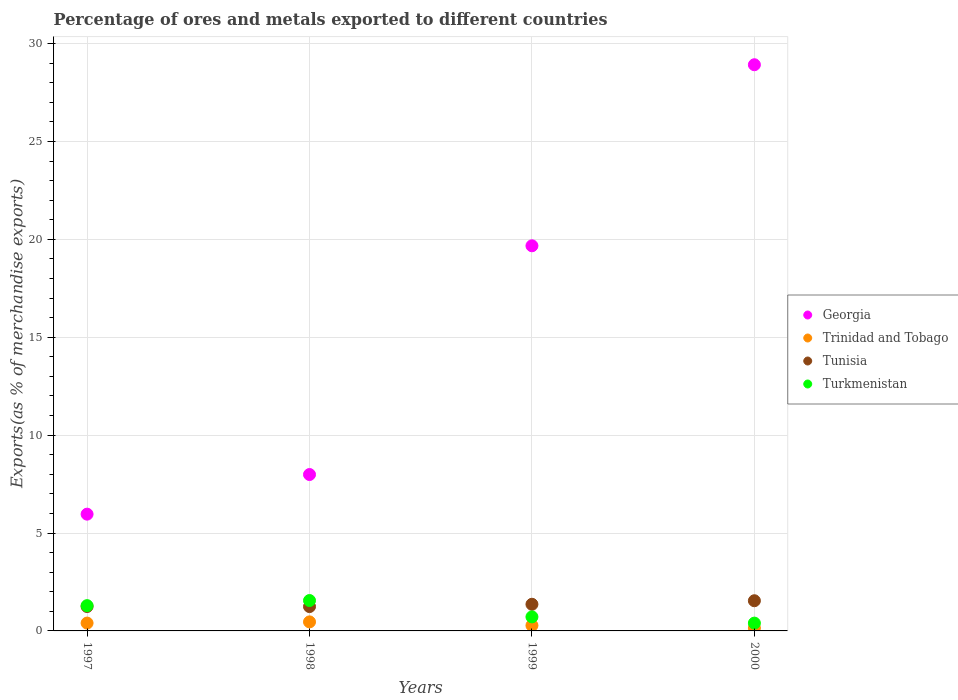Is the number of dotlines equal to the number of legend labels?
Provide a succinct answer. Yes. What is the percentage of exports to different countries in Trinidad and Tobago in 1999?
Make the answer very short. 0.28. Across all years, what is the maximum percentage of exports to different countries in Tunisia?
Your answer should be compact. 1.54. Across all years, what is the minimum percentage of exports to different countries in Trinidad and Tobago?
Keep it short and to the point. 0.15. In which year was the percentage of exports to different countries in Turkmenistan minimum?
Provide a succinct answer. 2000. What is the total percentage of exports to different countries in Georgia in the graph?
Your answer should be compact. 62.54. What is the difference between the percentage of exports to different countries in Trinidad and Tobago in 1998 and that in 2000?
Offer a very short reply. 0.31. What is the difference between the percentage of exports to different countries in Tunisia in 1998 and the percentage of exports to different countries in Trinidad and Tobago in 2000?
Your answer should be very brief. 1.1. What is the average percentage of exports to different countries in Trinidad and Tobago per year?
Make the answer very short. 0.32. In the year 2000, what is the difference between the percentage of exports to different countries in Tunisia and percentage of exports to different countries in Trinidad and Tobago?
Provide a succinct answer. 1.39. What is the ratio of the percentage of exports to different countries in Tunisia in 1998 to that in 2000?
Keep it short and to the point. 0.81. Is the percentage of exports to different countries in Georgia in 1997 less than that in 1998?
Make the answer very short. Yes. Is the difference between the percentage of exports to different countries in Tunisia in 1999 and 2000 greater than the difference between the percentage of exports to different countries in Trinidad and Tobago in 1999 and 2000?
Provide a short and direct response. No. What is the difference between the highest and the second highest percentage of exports to different countries in Tunisia?
Provide a short and direct response. 0.18. What is the difference between the highest and the lowest percentage of exports to different countries in Tunisia?
Give a very brief answer. 0.3. In how many years, is the percentage of exports to different countries in Turkmenistan greater than the average percentage of exports to different countries in Turkmenistan taken over all years?
Make the answer very short. 2. Is the sum of the percentage of exports to different countries in Georgia in 1997 and 1998 greater than the maximum percentage of exports to different countries in Tunisia across all years?
Give a very brief answer. Yes. Is it the case that in every year, the sum of the percentage of exports to different countries in Georgia and percentage of exports to different countries in Turkmenistan  is greater than the sum of percentage of exports to different countries in Tunisia and percentage of exports to different countries in Trinidad and Tobago?
Give a very brief answer. Yes. Is the percentage of exports to different countries in Georgia strictly greater than the percentage of exports to different countries in Turkmenistan over the years?
Your answer should be very brief. Yes. Is the percentage of exports to different countries in Georgia strictly less than the percentage of exports to different countries in Trinidad and Tobago over the years?
Make the answer very short. No. What is the difference between two consecutive major ticks on the Y-axis?
Offer a terse response. 5. Are the values on the major ticks of Y-axis written in scientific E-notation?
Your answer should be compact. No. Does the graph contain grids?
Offer a terse response. Yes. Where does the legend appear in the graph?
Offer a very short reply. Center right. How many legend labels are there?
Ensure brevity in your answer.  4. What is the title of the graph?
Your answer should be compact. Percentage of ores and metals exported to different countries. Does "Maldives" appear as one of the legend labels in the graph?
Keep it short and to the point. No. What is the label or title of the Y-axis?
Provide a succinct answer. Exports(as % of merchandise exports). What is the Exports(as % of merchandise exports) of Georgia in 1997?
Give a very brief answer. 5.96. What is the Exports(as % of merchandise exports) of Trinidad and Tobago in 1997?
Your answer should be very brief. 0.4. What is the Exports(as % of merchandise exports) of Tunisia in 1997?
Provide a short and direct response. 1.25. What is the Exports(as % of merchandise exports) of Turkmenistan in 1997?
Ensure brevity in your answer.  1.29. What is the Exports(as % of merchandise exports) in Georgia in 1998?
Offer a terse response. 7.99. What is the Exports(as % of merchandise exports) of Trinidad and Tobago in 1998?
Your response must be concise. 0.46. What is the Exports(as % of merchandise exports) in Tunisia in 1998?
Provide a succinct answer. 1.24. What is the Exports(as % of merchandise exports) of Turkmenistan in 1998?
Provide a succinct answer. 1.55. What is the Exports(as % of merchandise exports) of Georgia in 1999?
Your answer should be very brief. 19.67. What is the Exports(as % of merchandise exports) in Trinidad and Tobago in 1999?
Give a very brief answer. 0.28. What is the Exports(as % of merchandise exports) in Tunisia in 1999?
Keep it short and to the point. 1.36. What is the Exports(as % of merchandise exports) in Turkmenistan in 1999?
Give a very brief answer. 0.72. What is the Exports(as % of merchandise exports) of Georgia in 2000?
Keep it short and to the point. 28.92. What is the Exports(as % of merchandise exports) of Trinidad and Tobago in 2000?
Make the answer very short. 0.15. What is the Exports(as % of merchandise exports) of Tunisia in 2000?
Offer a terse response. 1.54. What is the Exports(as % of merchandise exports) in Turkmenistan in 2000?
Give a very brief answer. 0.4. Across all years, what is the maximum Exports(as % of merchandise exports) in Georgia?
Provide a succinct answer. 28.92. Across all years, what is the maximum Exports(as % of merchandise exports) of Trinidad and Tobago?
Provide a succinct answer. 0.46. Across all years, what is the maximum Exports(as % of merchandise exports) of Tunisia?
Offer a terse response. 1.54. Across all years, what is the maximum Exports(as % of merchandise exports) of Turkmenistan?
Offer a terse response. 1.55. Across all years, what is the minimum Exports(as % of merchandise exports) in Georgia?
Your answer should be very brief. 5.96. Across all years, what is the minimum Exports(as % of merchandise exports) of Trinidad and Tobago?
Your answer should be compact. 0.15. Across all years, what is the minimum Exports(as % of merchandise exports) of Tunisia?
Your answer should be compact. 1.24. Across all years, what is the minimum Exports(as % of merchandise exports) of Turkmenistan?
Provide a succinct answer. 0.4. What is the total Exports(as % of merchandise exports) in Georgia in the graph?
Make the answer very short. 62.54. What is the total Exports(as % of merchandise exports) in Trinidad and Tobago in the graph?
Give a very brief answer. 1.29. What is the total Exports(as % of merchandise exports) in Tunisia in the graph?
Ensure brevity in your answer.  5.39. What is the total Exports(as % of merchandise exports) in Turkmenistan in the graph?
Provide a short and direct response. 3.96. What is the difference between the Exports(as % of merchandise exports) in Georgia in 1997 and that in 1998?
Your answer should be compact. -2.02. What is the difference between the Exports(as % of merchandise exports) of Trinidad and Tobago in 1997 and that in 1998?
Offer a terse response. -0.06. What is the difference between the Exports(as % of merchandise exports) in Tunisia in 1997 and that in 1998?
Give a very brief answer. 0. What is the difference between the Exports(as % of merchandise exports) in Turkmenistan in 1997 and that in 1998?
Offer a terse response. -0.26. What is the difference between the Exports(as % of merchandise exports) of Georgia in 1997 and that in 1999?
Offer a very short reply. -13.71. What is the difference between the Exports(as % of merchandise exports) of Trinidad and Tobago in 1997 and that in 1999?
Provide a short and direct response. 0.12. What is the difference between the Exports(as % of merchandise exports) of Tunisia in 1997 and that in 1999?
Offer a very short reply. -0.11. What is the difference between the Exports(as % of merchandise exports) of Turkmenistan in 1997 and that in 1999?
Ensure brevity in your answer.  0.57. What is the difference between the Exports(as % of merchandise exports) of Georgia in 1997 and that in 2000?
Your answer should be compact. -22.95. What is the difference between the Exports(as % of merchandise exports) in Trinidad and Tobago in 1997 and that in 2000?
Keep it short and to the point. 0.25. What is the difference between the Exports(as % of merchandise exports) of Tunisia in 1997 and that in 2000?
Your response must be concise. -0.3. What is the difference between the Exports(as % of merchandise exports) in Turkmenistan in 1997 and that in 2000?
Make the answer very short. 0.89. What is the difference between the Exports(as % of merchandise exports) of Georgia in 1998 and that in 1999?
Offer a very short reply. -11.68. What is the difference between the Exports(as % of merchandise exports) in Trinidad and Tobago in 1998 and that in 1999?
Give a very brief answer. 0.18. What is the difference between the Exports(as % of merchandise exports) of Tunisia in 1998 and that in 1999?
Offer a very short reply. -0.12. What is the difference between the Exports(as % of merchandise exports) in Turkmenistan in 1998 and that in 1999?
Keep it short and to the point. 0.83. What is the difference between the Exports(as % of merchandise exports) in Georgia in 1998 and that in 2000?
Provide a short and direct response. -20.93. What is the difference between the Exports(as % of merchandise exports) in Trinidad and Tobago in 1998 and that in 2000?
Your response must be concise. 0.31. What is the difference between the Exports(as % of merchandise exports) in Tunisia in 1998 and that in 2000?
Your response must be concise. -0.3. What is the difference between the Exports(as % of merchandise exports) of Turkmenistan in 1998 and that in 2000?
Ensure brevity in your answer.  1.15. What is the difference between the Exports(as % of merchandise exports) of Georgia in 1999 and that in 2000?
Offer a terse response. -9.25. What is the difference between the Exports(as % of merchandise exports) in Trinidad and Tobago in 1999 and that in 2000?
Keep it short and to the point. 0.13. What is the difference between the Exports(as % of merchandise exports) of Tunisia in 1999 and that in 2000?
Ensure brevity in your answer.  -0.18. What is the difference between the Exports(as % of merchandise exports) in Turkmenistan in 1999 and that in 2000?
Make the answer very short. 0.32. What is the difference between the Exports(as % of merchandise exports) of Georgia in 1997 and the Exports(as % of merchandise exports) of Trinidad and Tobago in 1998?
Provide a short and direct response. 5.5. What is the difference between the Exports(as % of merchandise exports) in Georgia in 1997 and the Exports(as % of merchandise exports) in Tunisia in 1998?
Your answer should be compact. 4.72. What is the difference between the Exports(as % of merchandise exports) of Georgia in 1997 and the Exports(as % of merchandise exports) of Turkmenistan in 1998?
Offer a very short reply. 4.41. What is the difference between the Exports(as % of merchandise exports) of Trinidad and Tobago in 1997 and the Exports(as % of merchandise exports) of Tunisia in 1998?
Give a very brief answer. -0.84. What is the difference between the Exports(as % of merchandise exports) in Trinidad and Tobago in 1997 and the Exports(as % of merchandise exports) in Turkmenistan in 1998?
Your response must be concise. -1.15. What is the difference between the Exports(as % of merchandise exports) of Tunisia in 1997 and the Exports(as % of merchandise exports) of Turkmenistan in 1998?
Your answer should be very brief. -0.31. What is the difference between the Exports(as % of merchandise exports) in Georgia in 1997 and the Exports(as % of merchandise exports) in Trinidad and Tobago in 1999?
Offer a terse response. 5.69. What is the difference between the Exports(as % of merchandise exports) in Georgia in 1997 and the Exports(as % of merchandise exports) in Tunisia in 1999?
Your response must be concise. 4.6. What is the difference between the Exports(as % of merchandise exports) of Georgia in 1997 and the Exports(as % of merchandise exports) of Turkmenistan in 1999?
Ensure brevity in your answer.  5.25. What is the difference between the Exports(as % of merchandise exports) of Trinidad and Tobago in 1997 and the Exports(as % of merchandise exports) of Tunisia in 1999?
Ensure brevity in your answer.  -0.96. What is the difference between the Exports(as % of merchandise exports) of Trinidad and Tobago in 1997 and the Exports(as % of merchandise exports) of Turkmenistan in 1999?
Offer a terse response. -0.32. What is the difference between the Exports(as % of merchandise exports) in Tunisia in 1997 and the Exports(as % of merchandise exports) in Turkmenistan in 1999?
Give a very brief answer. 0.53. What is the difference between the Exports(as % of merchandise exports) of Georgia in 1997 and the Exports(as % of merchandise exports) of Trinidad and Tobago in 2000?
Offer a very short reply. 5.82. What is the difference between the Exports(as % of merchandise exports) in Georgia in 1997 and the Exports(as % of merchandise exports) in Tunisia in 2000?
Your answer should be very brief. 4.42. What is the difference between the Exports(as % of merchandise exports) of Georgia in 1997 and the Exports(as % of merchandise exports) of Turkmenistan in 2000?
Provide a short and direct response. 5.56. What is the difference between the Exports(as % of merchandise exports) in Trinidad and Tobago in 1997 and the Exports(as % of merchandise exports) in Tunisia in 2000?
Your response must be concise. -1.14. What is the difference between the Exports(as % of merchandise exports) in Trinidad and Tobago in 1997 and the Exports(as % of merchandise exports) in Turkmenistan in 2000?
Your answer should be compact. 0. What is the difference between the Exports(as % of merchandise exports) in Tunisia in 1997 and the Exports(as % of merchandise exports) in Turkmenistan in 2000?
Your answer should be compact. 0.85. What is the difference between the Exports(as % of merchandise exports) of Georgia in 1998 and the Exports(as % of merchandise exports) of Trinidad and Tobago in 1999?
Provide a short and direct response. 7.71. What is the difference between the Exports(as % of merchandise exports) of Georgia in 1998 and the Exports(as % of merchandise exports) of Tunisia in 1999?
Your answer should be compact. 6.63. What is the difference between the Exports(as % of merchandise exports) of Georgia in 1998 and the Exports(as % of merchandise exports) of Turkmenistan in 1999?
Your answer should be very brief. 7.27. What is the difference between the Exports(as % of merchandise exports) in Trinidad and Tobago in 1998 and the Exports(as % of merchandise exports) in Tunisia in 1999?
Make the answer very short. -0.9. What is the difference between the Exports(as % of merchandise exports) of Trinidad and Tobago in 1998 and the Exports(as % of merchandise exports) of Turkmenistan in 1999?
Give a very brief answer. -0.26. What is the difference between the Exports(as % of merchandise exports) of Tunisia in 1998 and the Exports(as % of merchandise exports) of Turkmenistan in 1999?
Your answer should be very brief. 0.53. What is the difference between the Exports(as % of merchandise exports) in Georgia in 1998 and the Exports(as % of merchandise exports) in Trinidad and Tobago in 2000?
Your answer should be very brief. 7.84. What is the difference between the Exports(as % of merchandise exports) of Georgia in 1998 and the Exports(as % of merchandise exports) of Tunisia in 2000?
Give a very brief answer. 6.45. What is the difference between the Exports(as % of merchandise exports) of Georgia in 1998 and the Exports(as % of merchandise exports) of Turkmenistan in 2000?
Make the answer very short. 7.59. What is the difference between the Exports(as % of merchandise exports) of Trinidad and Tobago in 1998 and the Exports(as % of merchandise exports) of Tunisia in 2000?
Provide a succinct answer. -1.08. What is the difference between the Exports(as % of merchandise exports) of Trinidad and Tobago in 1998 and the Exports(as % of merchandise exports) of Turkmenistan in 2000?
Keep it short and to the point. 0.06. What is the difference between the Exports(as % of merchandise exports) of Tunisia in 1998 and the Exports(as % of merchandise exports) of Turkmenistan in 2000?
Your answer should be compact. 0.84. What is the difference between the Exports(as % of merchandise exports) of Georgia in 1999 and the Exports(as % of merchandise exports) of Trinidad and Tobago in 2000?
Provide a succinct answer. 19.52. What is the difference between the Exports(as % of merchandise exports) of Georgia in 1999 and the Exports(as % of merchandise exports) of Tunisia in 2000?
Keep it short and to the point. 18.13. What is the difference between the Exports(as % of merchandise exports) in Georgia in 1999 and the Exports(as % of merchandise exports) in Turkmenistan in 2000?
Your answer should be compact. 19.27. What is the difference between the Exports(as % of merchandise exports) of Trinidad and Tobago in 1999 and the Exports(as % of merchandise exports) of Tunisia in 2000?
Provide a short and direct response. -1.26. What is the difference between the Exports(as % of merchandise exports) in Trinidad and Tobago in 1999 and the Exports(as % of merchandise exports) in Turkmenistan in 2000?
Your answer should be compact. -0.12. What is the difference between the Exports(as % of merchandise exports) of Tunisia in 1999 and the Exports(as % of merchandise exports) of Turkmenistan in 2000?
Offer a very short reply. 0.96. What is the average Exports(as % of merchandise exports) of Georgia per year?
Offer a terse response. 15.63. What is the average Exports(as % of merchandise exports) in Trinidad and Tobago per year?
Keep it short and to the point. 0.32. What is the average Exports(as % of merchandise exports) in Tunisia per year?
Ensure brevity in your answer.  1.35. In the year 1997, what is the difference between the Exports(as % of merchandise exports) in Georgia and Exports(as % of merchandise exports) in Trinidad and Tobago?
Give a very brief answer. 5.56. In the year 1997, what is the difference between the Exports(as % of merchandise exports) of Georgia and Exports(as % of merchandise exports) of Tunisia?
Offer a terse response. 4.72. In the year 1997, what is the difference between the Exports(as % of merchandise exports) in Georgia and Exports(as % of merchandise exports) in Turkmenistan?
Your answer should be compact. 4.67. In the year 1997, what is the difference between the Exports(as % of merchandise exports) in Trinidad and Tobago and Exports(as % of merchandise exports) in Tunisia?
Your answer should be very brief. -0.85. In the year 1997, what is the difference between the Exports(as % of merchandise exports) of Trinidad and Tobago and Exports(as % of merchandise exports) of Turkmenistan?
Offer a very short reply. -0.89. In the year 1997, what is the difference between the Exports(as % of merchandise exports) of Tunisia and Exports(as % of merchandise exports) of Turkmenistan?
Ensure brevity in your answer.  -0.04. In the year 1998, what is the difference between the Exports(as % of merchandise exports) of Georgia and Exports(as % of merchandise exports) of Trinidad and Tobago?
Your response must be concise. 7.53. In the year 1998, what is the difference between the Exports(as % of merchandise exports) of Georgia and Exports(as % of merchandise exports) of Tunisia?
Make the answer very short. 6.74. In the year 1998, what is the difference between the Exports(as % of merchandise exports) of Georgia and Exports(as % of merchandise exports) of Turkmenistan?
Your response must be concise. 6.44. In the year 1998, what is the difference between the Exports(as % of merchandise exports) of Trinidad and Tobago and Exports(as % of merchandise exports) of Tunisia?
Your answer should be very brief. -0.78. In the year 1998, what is the difference between the Exports(as % of merchandise exports) in Trinidad and Tobago and Exports(as % of merchandise exports) in Turkmenistan?
Give a very brief answer. -1.09. In the year 1998, what is the difference between the Exports(as % of merchandise exports) of Tunisia and Exports(as % of merchandise exports) of Turkmenistan?
Your answer should be compact. -0.31. In the year 1999, what is the difference between the Exports(as % of merchandise exports) in Georgia and Exports(as % of merchandise exports) in Trinidad and Tobago?
Your answer should be compact. 19.39. In the year 1999, what is the difference between the Exports(as % of merchandise exports) of Georgia and Exports(as % of merchandise exports) of Tunisia?
Offer a very short reply. 18.31. In the year 1999, what is the difference between the Exports(as % of merchandise exports) in Georgia and Exports(as % of merchandise exports) in Turkmenistan?
Make the answer very short. 18.95. In the year 1999, what is the difference between the Exports(as % of merchandise exports) of Trinidad and Tobago and Exports(as % of merchandise exports) of Tunisia?
Provide a short and direct response. -1.08. In the year 1999, what is the difference between the Exports(as % of merchandise exports) in Trinidad and Tobago and Exports(as % of merchandise exports) in Turkmenistan?
Make the answer very short. -0.44. In the year 1999, what is the difference between the Exports(as % of merchandise exports) of Tunisia and Exports(as % of merchandise exports) of Turkmenistan?
Provide a succinct answer. 0.64. In the year 2000, what is the difference between the Exports(as % of merchandise exports) of Georgia and Exports(as % of merchandise exports) of Trinidad and Tobago?
Ensure brevity in your answer.  28.77. In the year 2000, what is the difference between the Exports(as % of merchandise exports) in Georgia and Exports(as % of merchandise exports) in Tunisia?
Make the answer very short. 27.38. In the year 2000, what is the difference between the Exports(as % of merchandise exports) of Georgia and Exports(as % of merchandise exports) of Turkmenistan?
Offer a terse response. 28.52. In the year 2000, what is the difference between the Exports(as % of merchandise exports) in Trinidad and Tobago and Exports(as % of merchandise exports) in Tunisia?
Make the answer very short. -1.39. In the year 2000, what is the difference between the Exports(as % of merchandise exports) in Trinidad and Tobago and Exports(as % of merchandise exports) in Turkmenistan?
Offer a very short reply. -0.25. In the year 2000, what is the difference between the Exports(as % of merchandise exports) of Tunisia and Exports(as % of merchandise exports) of Turkmenistan?
Offer a terse response. 1.14. What is the ratio of the Exports(as % of merchandise exports) in Georgia in 1997 to that in 1998?
Offer a very short reply. 0.75. What is the ratio of the Exports(as % of merchandise exports) in Trinidad and Tobago in 1997 to that in 1998?
Make the answer very short. 0.87. What is the ratio of the Exports(as % of merchandise exports) in Tunisia in 1997 to that in 1998?
Make the answer very short. 1. What is the ratio of the Exports(as % of merchandise exports) in Turkmenistan in 1997 to that in 1998?
Offer a terse response. 0.83. What is the ratio of the Exports(as % of merchandise exports) in Georgia in 1997 to that in 1999?
Provide a succinct answer. 0.3. What is the ratio of the Exports(as % of merchandise exports) in Trinidad and Tobago in 1997 to that in 1999?
Offer a terse response. 1.44. What is the ratio of the Exports(as % of merchandise exports) of Tunisia in 1997 to that in 1999?
Your answer should be very brief. 0.92. What is the ratio of the Exports(as % of merchandise exports) in Turkmenistan in 1997 to that in 1999?
Offer a very short reply. 1.8. What is the ratio of the Exports(as % of merchandise exports) of Georgia in 1997 to that in 2000?
Offer a very short reply. 0.21. What is the ratio of the Exports(as % of merchandise exports) in Trinidad and Tobago in 1997 to that in 2000?
Your answer should be very brief. 2.73. What is the ratio of the Exports(as % of merchandise exports) in Tunisia in 1997 to that in 2000?
Give a very brief answer. 0.81. What is the ratio of the Exports(as % of merchandise exports) of Turkmenistan in 1997 to that in 2000?
Your answer should be compact. 3.24. What is the ratio of the Exports(as % of merchandise exports) of Georgia in 1998 to that in 1999?
Keep it short and to the point. 0.41. What is the ratio of the Exports(as % of merchandise exports) of Trinidad and Tobago in 1998 to that in 1999?
Provide a succinct answer. 1.66. What is the ratio of the Exports(as % of merchandise exports) of Tunisia in 1998 to that in 1999?
Your answer should be compact. 0.91. What is the ratio of the Exports(as % of merchandise exports) in Turkmenistan in 1998 to that in 1999?
Offer a terse response. 2.16. What is the ratio of the Exports(as % of merchandise exports) in Georgia in 1998 to that in 2000?
Offer a very short reply. 0.28. What is the ratio of the Exports(as % of merchandise exports) of Trinidad and Tobago in 1998 to that in 2000?
Ensure brevity in your answer.  3.15. What is the ratio of the Exports(as % of merchandise exports) in Tunisia in 1998 to that in 2000?
Provide a succinct answer. 0.81. What is the ratio of the Exports(as % of merchandise exports) of Turkmenistan in 1998 to that in 2000?
Keep it short and to the point. 3.89. What is the ratio of the Exports(as % of merchandise exports) in Georgia in 1999 to that in 2000?
Make the answer very short. 0.68. What is the ratio of the Exports(as % of merchandise exports) of Trinidad and Tobago in 1999 to that in 2000?
Offer a terse response. 1.9. What is the ratio of the Exports(as % of merchandise exports) in Tunisia in 1999 to that in 2000?
Offer a terse response. 0.88. What is the ratio of the Exports(as % of merchandise exports) in Turkmenistan in 1999 to that in 2000?
Your answer should be very brief. 1.8. What is the difference between the highest and the second highest Exports(as % of merchandise exports) of Georgia?
Keep it short and to the point. 9.25. What is the difference between the highest and the second highest Exports(as % of merchandise exports) of Trinidad and Tobago?
Provide a succinct answer. 0.06. What is the difference between the highest and the second highest Exports(as % of merchandise exports) in Tunisia?
Your answer should be very brief. 0.18. What is the difference between the highest and the second highest Exports(as % of merchandise exports) in Turkmenistan?
Keep it short and to the point. 0.26. What is the difference between the highest and the lowest Exports(as % of merchandise exports) of Georgia?
Provide a succinct answer. 22.95. What is the difference between the highest and the lowest Exports(as % of merchandise exports) of Trinidad and Tobago?
Provide a succinct answer. 0.31. What is the difference between the highest and the lowest Exports(as % of merchandise exports) of Tunisia?
Your response must be concise. 0.3. What is the difference between the highest and the lowest Exports(as % of merchandise exports) in Turkmenistan?
Provide a short and direct response. 1.15. 